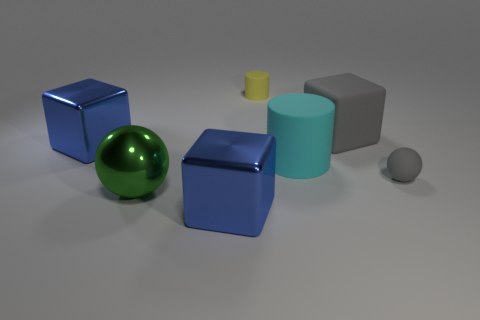Subtract all big blue blocks. How many blocks are left? 1 Subtract all yellow cylinders. How many blue blocks are left? 2 Add 3 large gray cylinders. How many objects exist? 10 Subtract all balls. How many objects are left? 5 Subtract 1 gray blocks. How many objects are left? 6 Subtract all yellow cubes. Subtract all brown spheres. How many cubes are left? 3 Subtract all small yellow cylinders. Subtract all tiny gray rubber things. How many objects are left? 5 Add 7 big green metal things. How many big green metal things are left? 8 Add 2 big green metallic things. How many big green metallic things exist? 3 